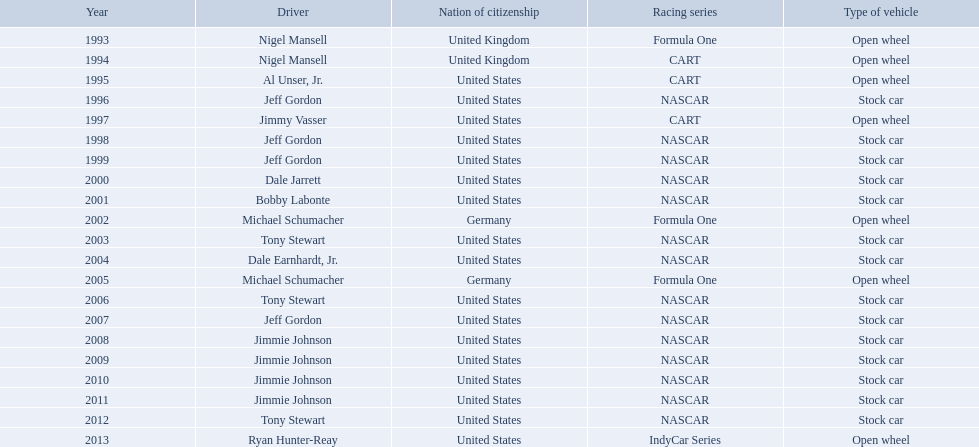Who won an espy in the year 2004, bobby labonte, tony stewart, dale earnhardt jr., or jeff gordon? Dale Earnhardt, Jr. Who won the espy in the year 1997; nigel mansell, al unser, jr., jeff gordon, or jimmy vasser? Jimmy Vasser. Which one only has one espy; nigel mansell, al unser jr., michael schumacher, or jeff gordon? Al Unser, Jr. In which year(s) was nigel mansel awarded epsy awards? 1993, 1994. In which year(s) was michael schumacher awarded epsy awards? 2002, 2005. In which year(s) was jeff gordon awarded epsy awards? 1996, 1998, 1999, 2007. In which year(s) was al unser jr. awarded epsy awards? 1995. Which of these drivers received only a single epsy award? Al Unser, Jr. During which year(s) did nigel mansel earn epsy awards? 1993, 1994. During which year(s) did michael schumacher earn epsy awards? 2002, 2005. During which year(s) did jeff gordon earn epsy awards? 1996, 1998, 1999, 2007. During which year(s) did al unser jr. earn epsy awards? 1995. Which among these drivers was given just one epsy award? Al Unser, Jr. 